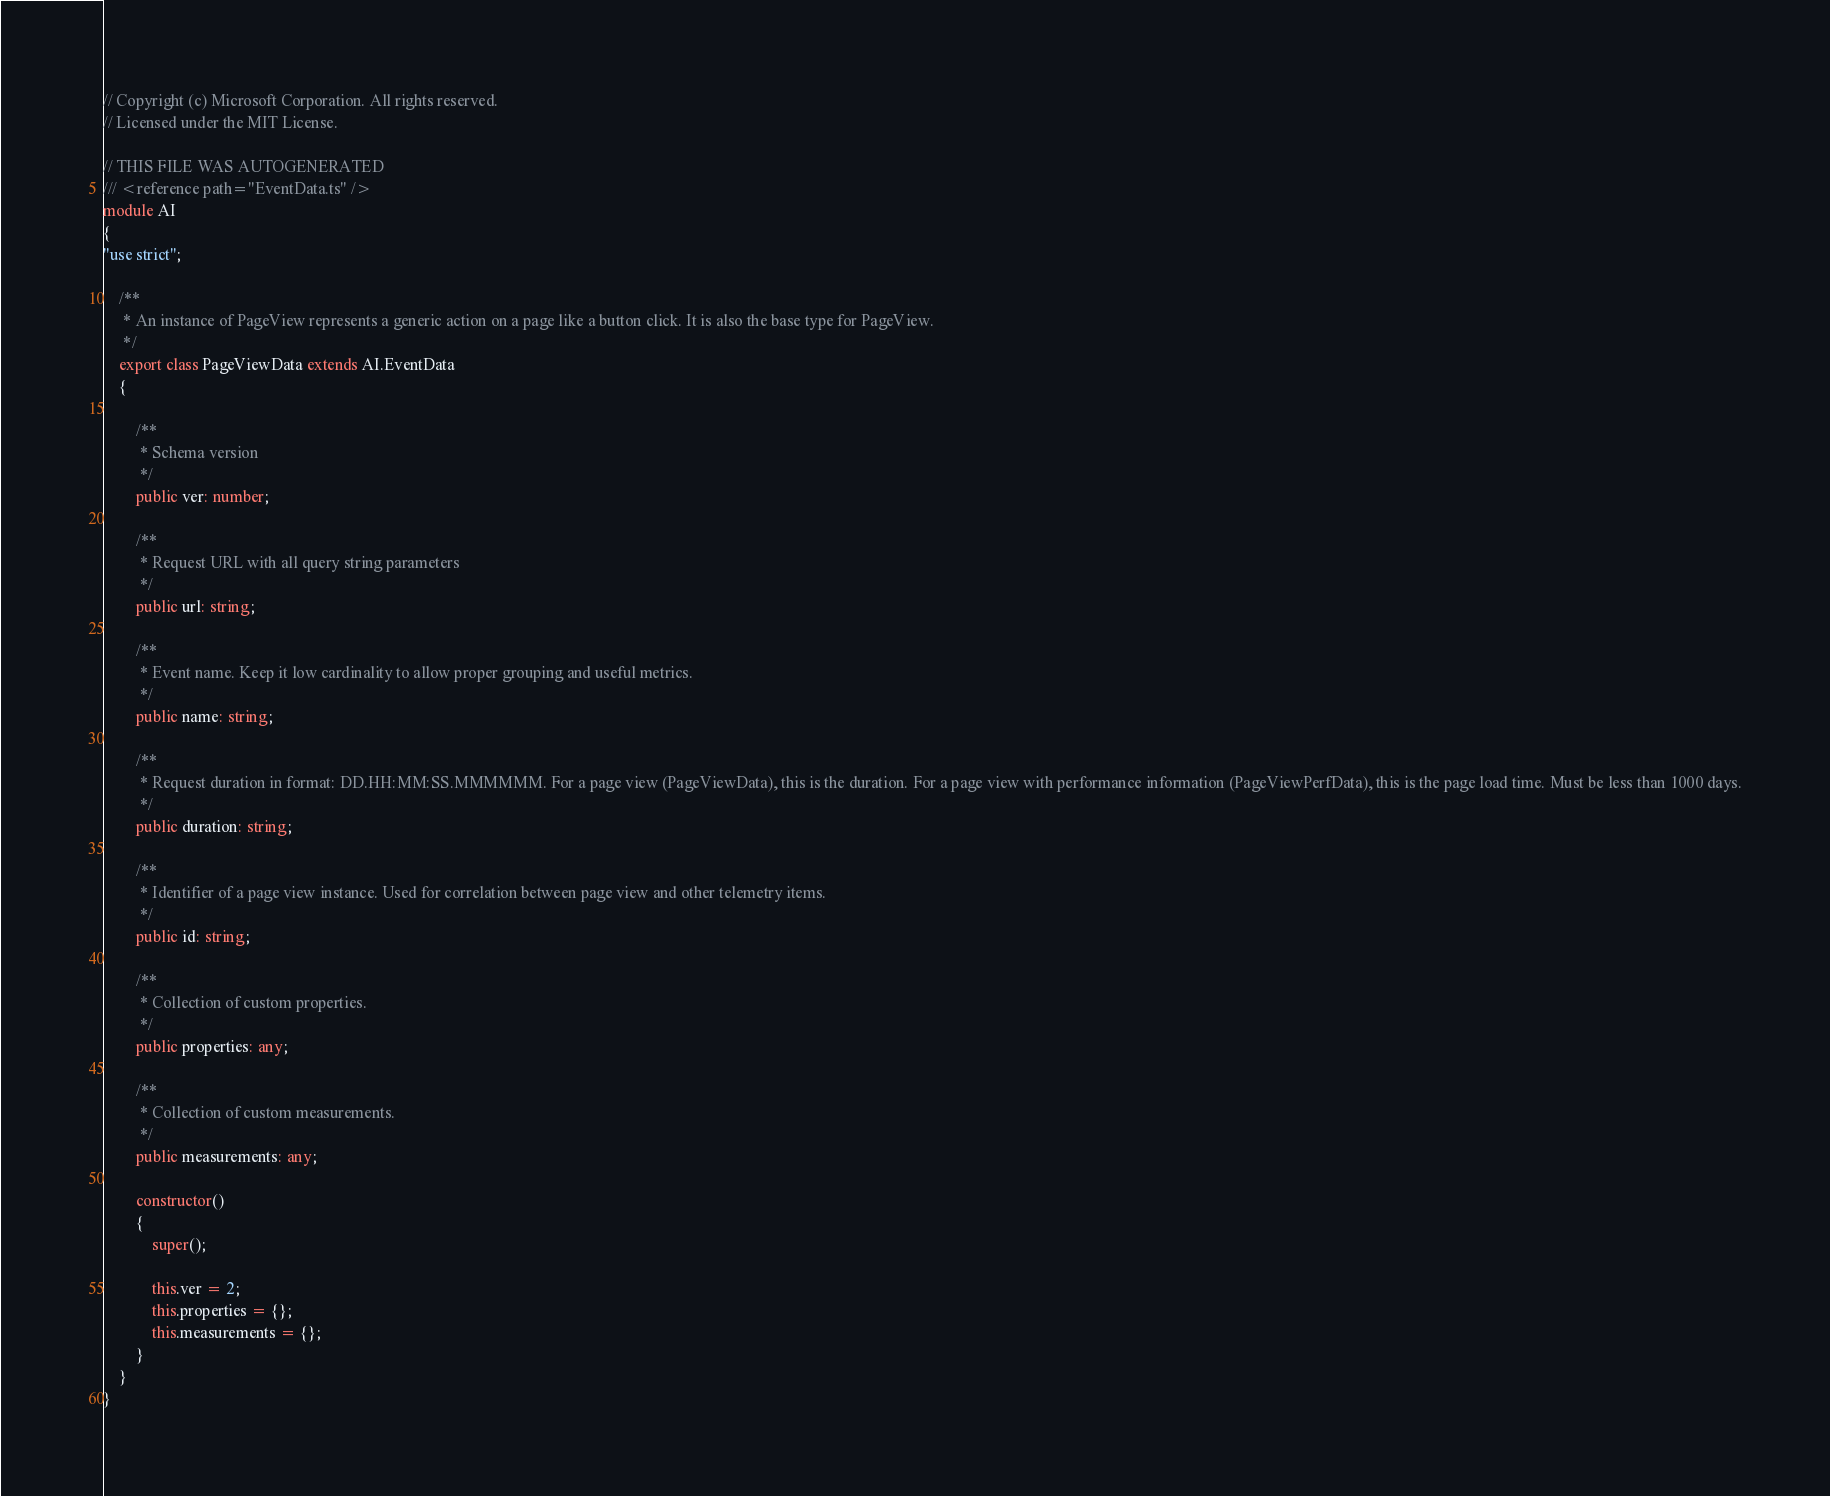<code> <loc_0><loc_0><loc_500><loc_500><_TypeScript_>// Copyright (c) Microsoft Corporation. All rights reserved.
// Licensed under the MIT License.

// THIS FILE WAS AUTOGENERATED
/// <reference path="EventData.ts" />
module AI
{
"use strict";
    
    /**
     * An instance of PageView represents a generic action on a page like a button click. It is also the base type for PageView.
     */
    export class PageViewData extends AI.EventData
    {
        
        /**
         * Schema version
         */
        public ver: number;
        
        /**
         * Request URL with all query string parameters
         */
        public url: string;
        
        /**
         * Event name. Keep it low cardinality to allow proper grouping and useful metrics.
         */
        public name: string;
        
        /**
         * Request duration in format: DD.HH:MM:SS.MMMMMM. For a page view (PageViewData), this is the duration. For a page view with performance information (PageViewPerfData), this is the page load time. Must be less than 1000 days.
         */
        public duration: string;
               
        /**
         * Identifier of a page view instance. Used for correlation between page view and other telemetry items.
         */
        public id: string;
        
        /**
         * Collection of custom properties.
         */
        public properties: any;
        
        /**
         * Collection of custom measurements.
         */
        public measurements: any;
        
        constructor()
        {
            super();
            
            this.ver = 2;
            this.properties = {};
            this.measurements = {};
        }
    }
}
</code> 